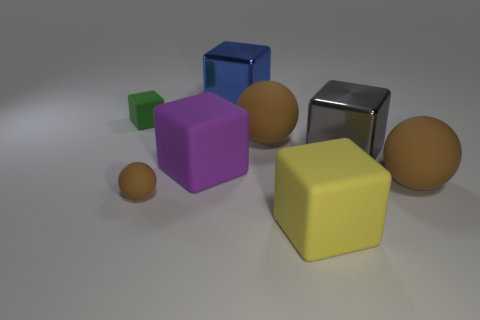How many brown balls must be subtracted to get 1 brown balls? 2 Subtract all large purple cubes. How many cubes are left? 4 Subtract all gray cubes. How many cubes are left? 4 Add 1 big metal things. How many objects exist? 9 Subtract all purple blocks. Subtract all blue balls. How many blocks are left? 4 Subtract all cubes. How many objects are left? 3 Subtract 1 gray cubes. How many objects are left? 7 Subtract all cylinders. Subtract all big balls. How many objects are left? 6 Add 3 large objects. How many large objects are left? 9 Add 4 blue matte objects. How many blue matte objects exist? 4 